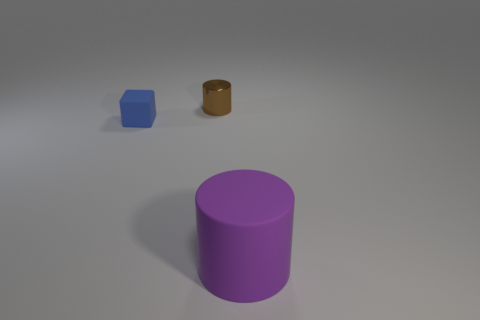Add 2 green shiny things. How many objects exist? 5 Subtract all blocks. How many objects are left? 2 Add 2 small brown cylinders. How many small brown cylinders are left? 3 Add 3 tiny green metallic objects. How many tiny green metallic objects exist? 3 Subtract 0 cyan cylinders. How many objects are left? 3 Subtract all shiny cylinders. Subtract all big purple cylinders. How many objects are left? 1 